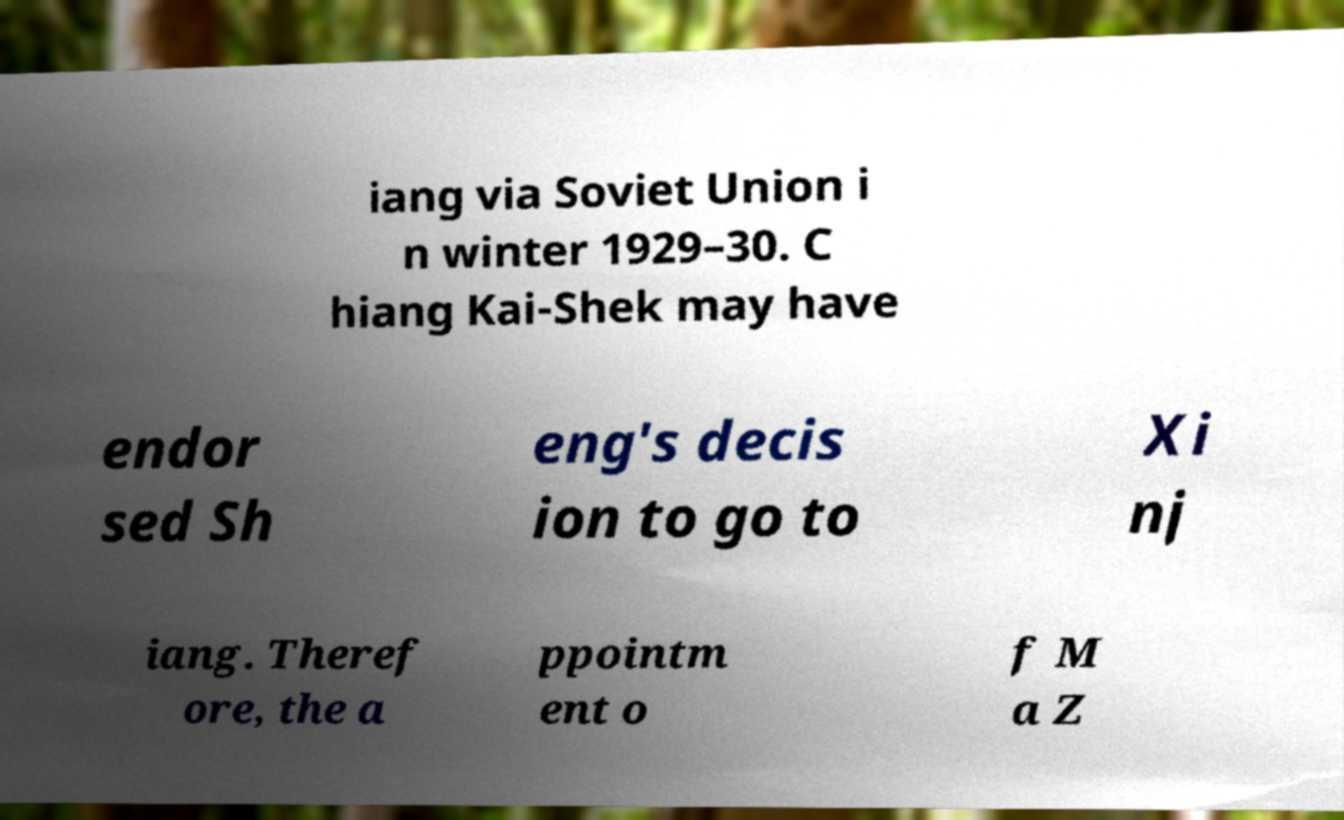I need the written content from this picture converted into text. Can you do that? iang via Soviet Union i n winter 1929–30. C hiang Kai-Shek may have endor sed Sh eng's decis ion to go to Xi nj iang. Theref ore, the a ppointm ent o f M a Z 